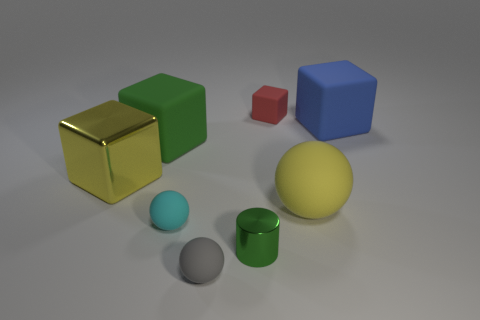How many objects are large objects that are right of the tiny red rubber object or blocks to the right of the gray rubber ball?
Offer a very short reply. 3. What is the shape of the big yellow thing that is made of the same material as the tiny green object?
Provide a short and direct response. Cube. Is there anything else that is the same color as the metallic block?
Give a very brief answer. Yes. What is the material of the small cyan thing that is the same shape as the large yellow rubber object?
Offer a terse response. Rubber. How many other things are the same size as the cyan matte object?
Provide a short and direct response. 3. What is the large blue cube made of?
Offer a terse response. Rubber. Are there more tiny red things that are right of the small shiny thing than large cyan cubes?
Keep it short and to the point. Yes. Is there a tiny metallic block?
Provide a short and direct response. No. How many other objects are there of the same shape as the blue rubber thing?
Ensure brevity in your answer.  3. Does the small matte ball that is on the left side of the gray matte thing have the same color as the rubber block to the left of the small red thing?
Your answer should be compact. No. 